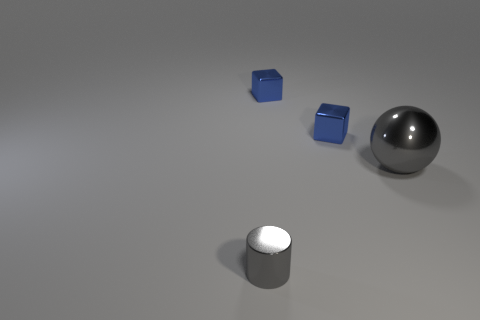Add 2 tiny blue metallic cubes. How many objects exist? 6 Subtract all cylinders. How many objects are left? 3 Subtract 0 blue spheres. How many objects are left? 4 Subtract all tiny gray cubes. Subtract all large shiny spheres. How many objects are left? 3 Add 3 small blue blocks. How many small blue blocks are left? 5 Add 1 blue blocks. How many blue blocks exist? 3 